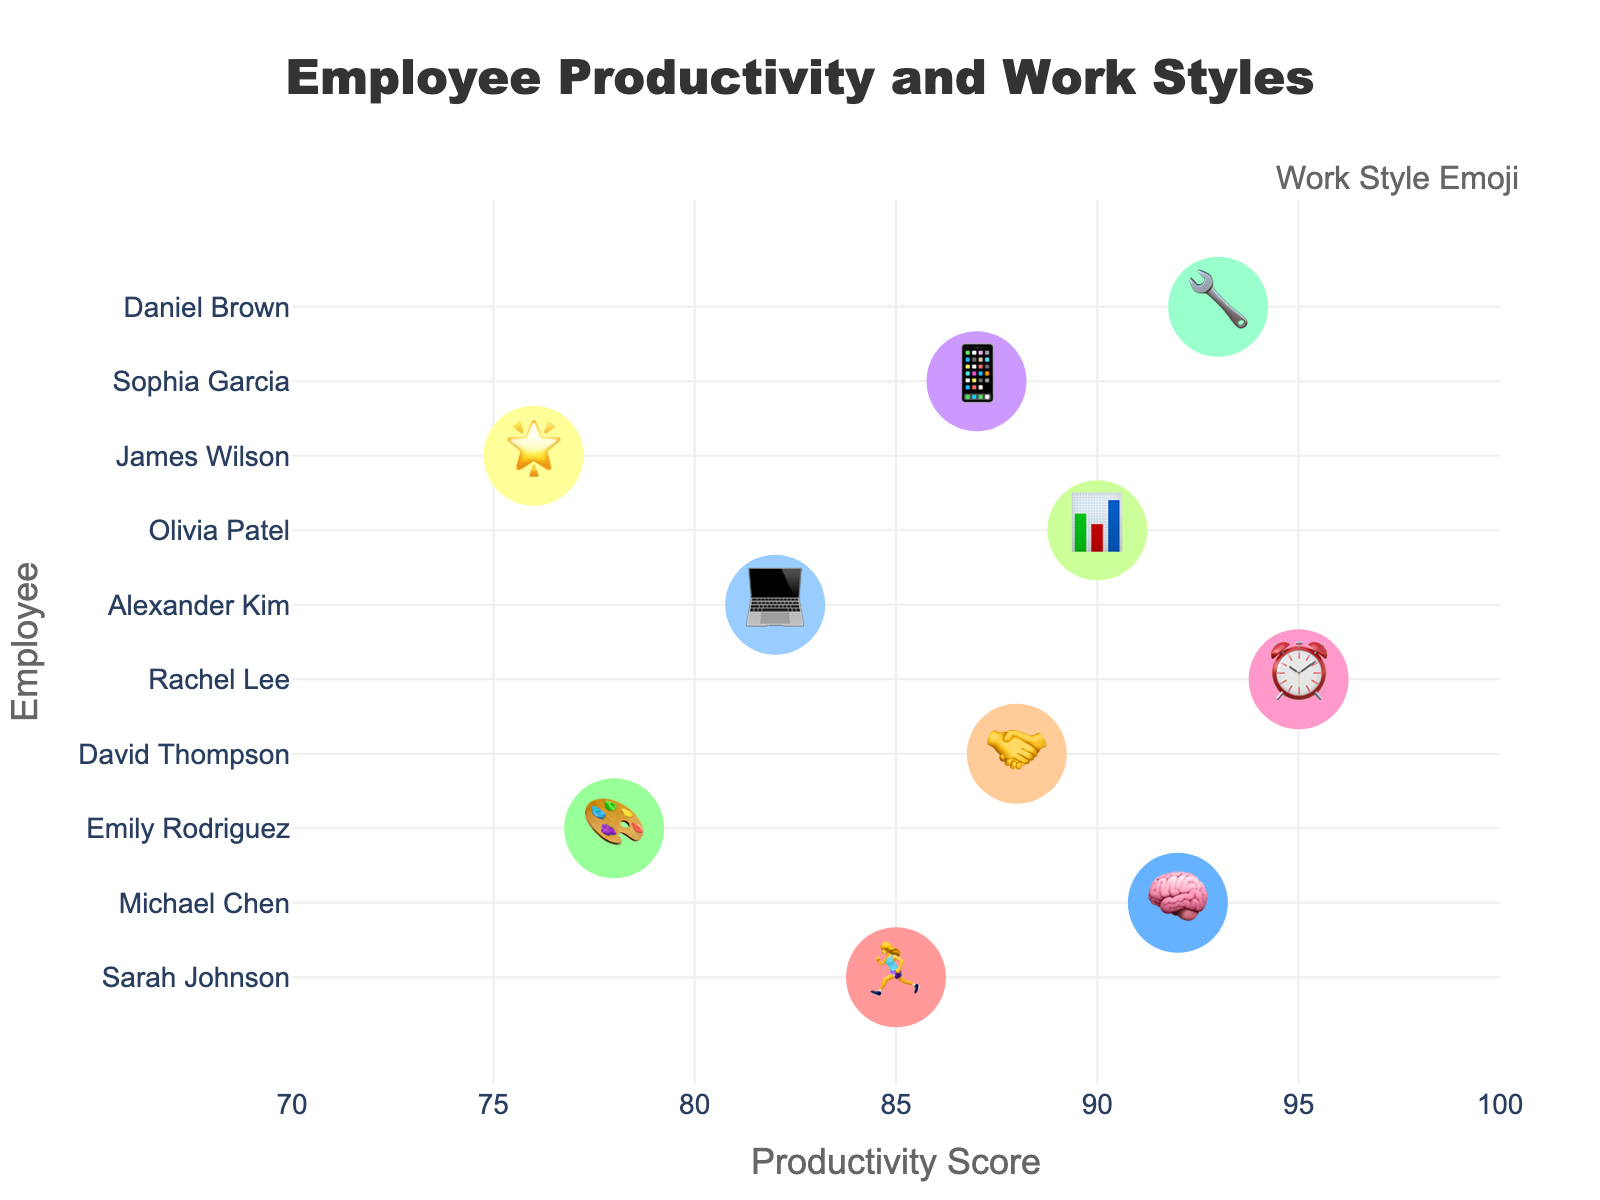What is the title of the chart? The title of the chart is displayed prominently at the top. Simply read the text in the title area.
Answer: Employee Productivity and Work Styles Which employee has the highest productivity score? Scan the x-axis values to identify the highest number and check the associated employee label.
Answer: Rachel Lee What work style emoji does Olivia Patel use? Locate Olivia Patel's name on the y-axis and observe the emoji in her corresponding marker.
Answer: 📊 What is the range of productivity scores shown on the x-axis? Examine the x-axis to determine the minimum and maximum values displayed.
Answer: 70 to 100 Who has a productivity score of 78? Look at the x-axis, find the score of 78, and trace it to the corresponding employee on the y-axis.
Answer: Emily Rodriguez Which two employees have the closest productivity scores? Compare the productivity scores of all employees to find the smallest difference between any two scores.
Answer: Sarah Johnson and Alexander Kim How many employees have a productivity score above 90? Count the number of markers to the right of the 90 mark on the x-axis.
Answer: 4 What are the productivity scores for Michael Chen and Daniel Brown? Locate Michael Chen and Daniel Brown on the y-axis and read their corresponding x-axis values.
Answer: 92 and 93 Compare the productivity scores of David Thompson and Sophia Garcia. Who is more productive? Find the scores for David Thompson and Sophia Garcia from the x-axis and compare them directly.
Answer: David Thompson What is the average productivity score of all employees? Sum all the productivity scores and divide by the total number of employees (10). Calculation steps: (85 + 92 + 78 + 88 + 95 + 82 + 90 + 76 + 87 + 93) / 10 = 86.6
Answer: 86.6 